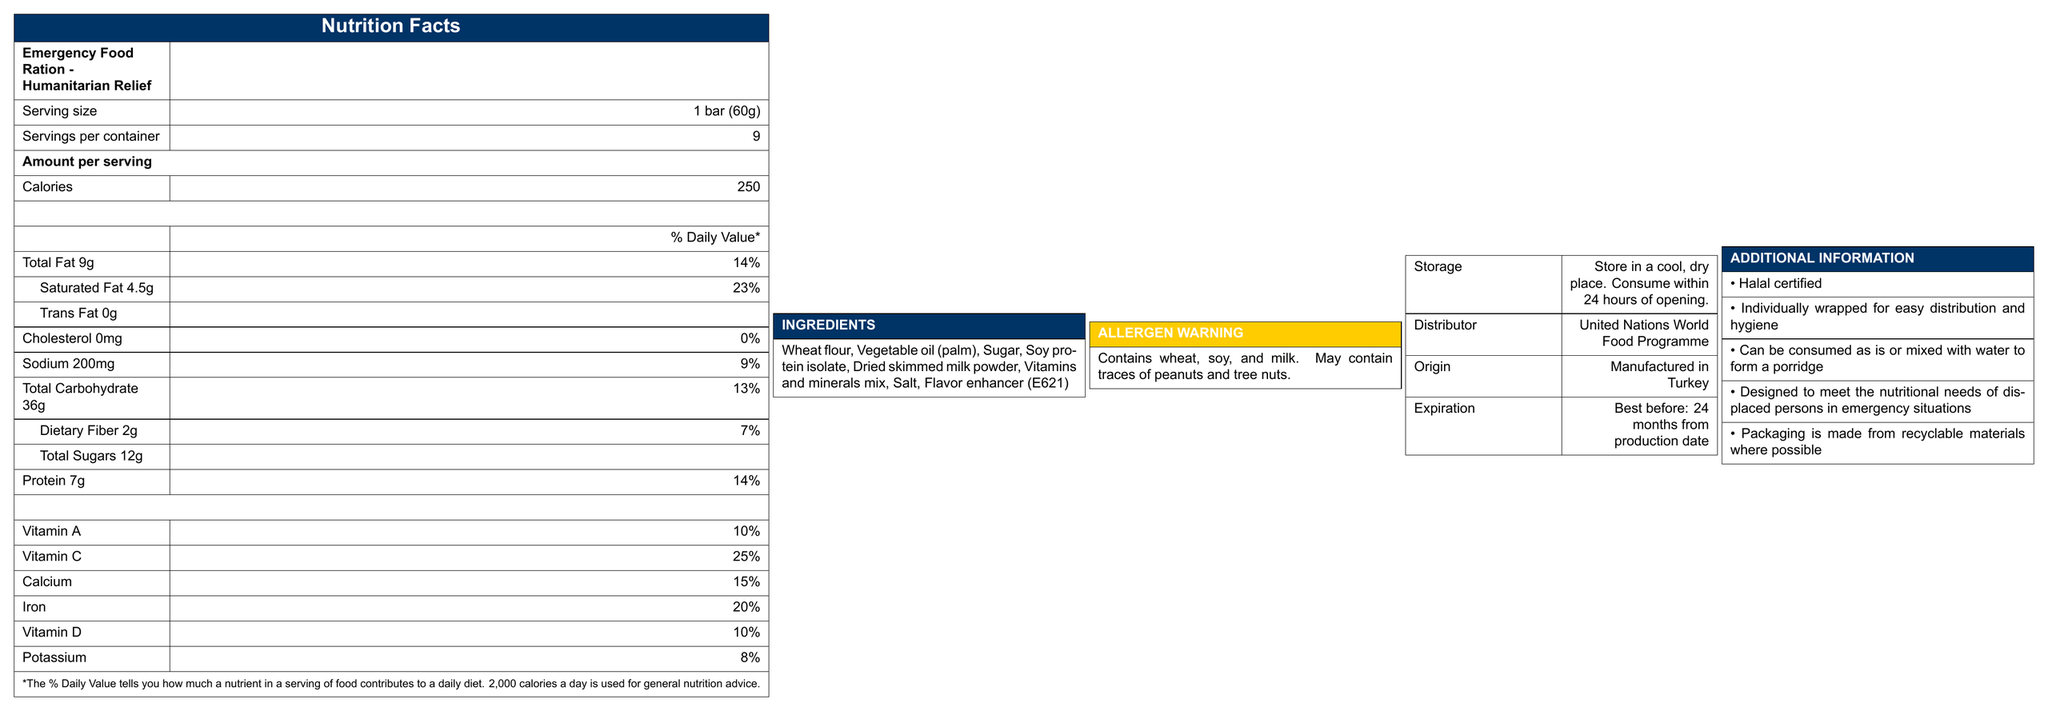What is the serving size of the emergency food ration? The serving size is specified as "1 bar (60g)" in the document.
Answer: 1 bar (60g) How many calories are in one serving of the emergency food ration? The document states that there are "250" calories per serving.
Answer: 250 calories What percentage of the daily value does the saturated fat content represent? The document mentions that Saturated Fat 4.5g corresponds to 23% of the daily value.
Answer: 23% What is the total carbohydrate content per serving? The total carbohydrate content is provided as "36g" in the document.
Answer: 36g Which vitamins and minerals are listed in the Nutrition Facts? The Nutrition Facts section lists Vitamin A, Vitamin C, Calcium, Iron, Vitamin D, and Potassium with their respective daily values.
Answer: Vitamin A, Vitamin C, Calcium, Iron, Vitamin D, Potassium What are the main ingredients in the emergency food ration? A. Wheat flour, sugar, salt B. Wheat flour, palm oil, soy protein isolate C. Sugar, salt, flavor enhancer The main ingredients listed are Wheat flour, Vegetable oil (palm), Sugar, Soy protein isolate, etc.
Answer: B. Wheat flour, palm oil, soy protein isolate How many servings are contained in one package of the emergency food ration? A. 6 B. 8 C. 9 The document states there are "9" servings per container.
Answer: C. 9 Is this food suitable for individuals with sesame allergies? The allergen information indicates that the product contains wheat, soy, and milk, and may contain traces of peanuts and tree nuts, but it doesn't mention sesame.
Answer: No Is the emergency food ration Halal certified? In the additional information, it states that the product is "Halal certified".
Answer: Yes Summarize the main purpose of this document. The document gives a comprehensive understanding of the nutritional values, contents, and proper usage and storage instructions of the emergency food ration.
Answer: The document provides nutritional information and additional details about the Emergency Food Ration - Humanitarian Relief, distributed by the United Nations World Food Programme. It includes data on calorie content, fat, cholesterol, sodium, carbohydrates, proteins, vitamins, and minerals per serving, as well as ingredients, allergen information, storage instructions, and other relevant details to ensure it meets the needs of displaced persons in emergency situations. What is the sodium content per serving? The Nutrition Facts section specifies that there is "200mg" of sodium per serving.
Answer: 200mg Where is this emergency food ration manufactured? The document states that the product is "Manufactured in Turkey".
Answer: Turkey Can the emergency food ration be consumed by individuals who are lactose intolerant? The allergen information mentions that the product contains milk, but it does not specifically address lactose intolerance.
Answer: Not enough information What is the expiration date of the emergency food ration? Expiration information is provided as "Best before: 24 months from production date".
Answer: Best before: 24 months from production date What is the purpose of the Vitamin and Mineral mix in the ingredients? The document does not provide specific information on the purpose of the Vitamin and Mineral mix.
Answer: I don't know 